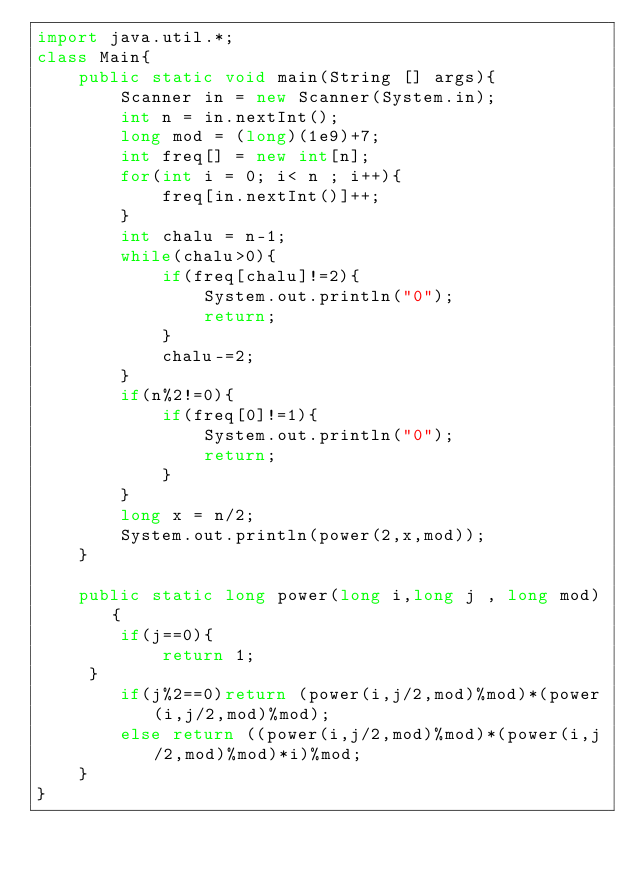Convert code to text. <code><loc_0><loc_0><loc_500><loc_500><_Java_>import java.util.*;
class Main{
	public static void main(String [] args){
    	Scanner in = new Scanner(System.in);
      	int n = in.nextInt();
      	long mod = (long)(1e9)+7;
      	int freq[] = new int[n];
      	for(int i = 0; i< n ; i++){
        	freq[in.nextInt()]++;
        }
      	int chalu = n-1;
      	while(chalu>0){
          	if(freq[chalu]!=2){
            	System.out.println("0");
              	return;
            }
        	chalu-=2;
        }
      	if(n%2!=0){
        	if(freq[0]!=1){
            	System.out.println("0");
              	return;
            }
        }
      	long x = n/2;
      	System.out.println(power(2,x,mod));
    }
  	
    public static long power(long i,long j , long mod){
        if(j==0){
            return 1;
     }
        if(j%2==0)return (power(i,j/2,mod)%mod)*(power(i,j/2,mod)%mod);
        else return ((power(i,j/2,mod)%mod)*(power(i,j/2,mod)%mod)*i)%mod;
    }
}</code> 